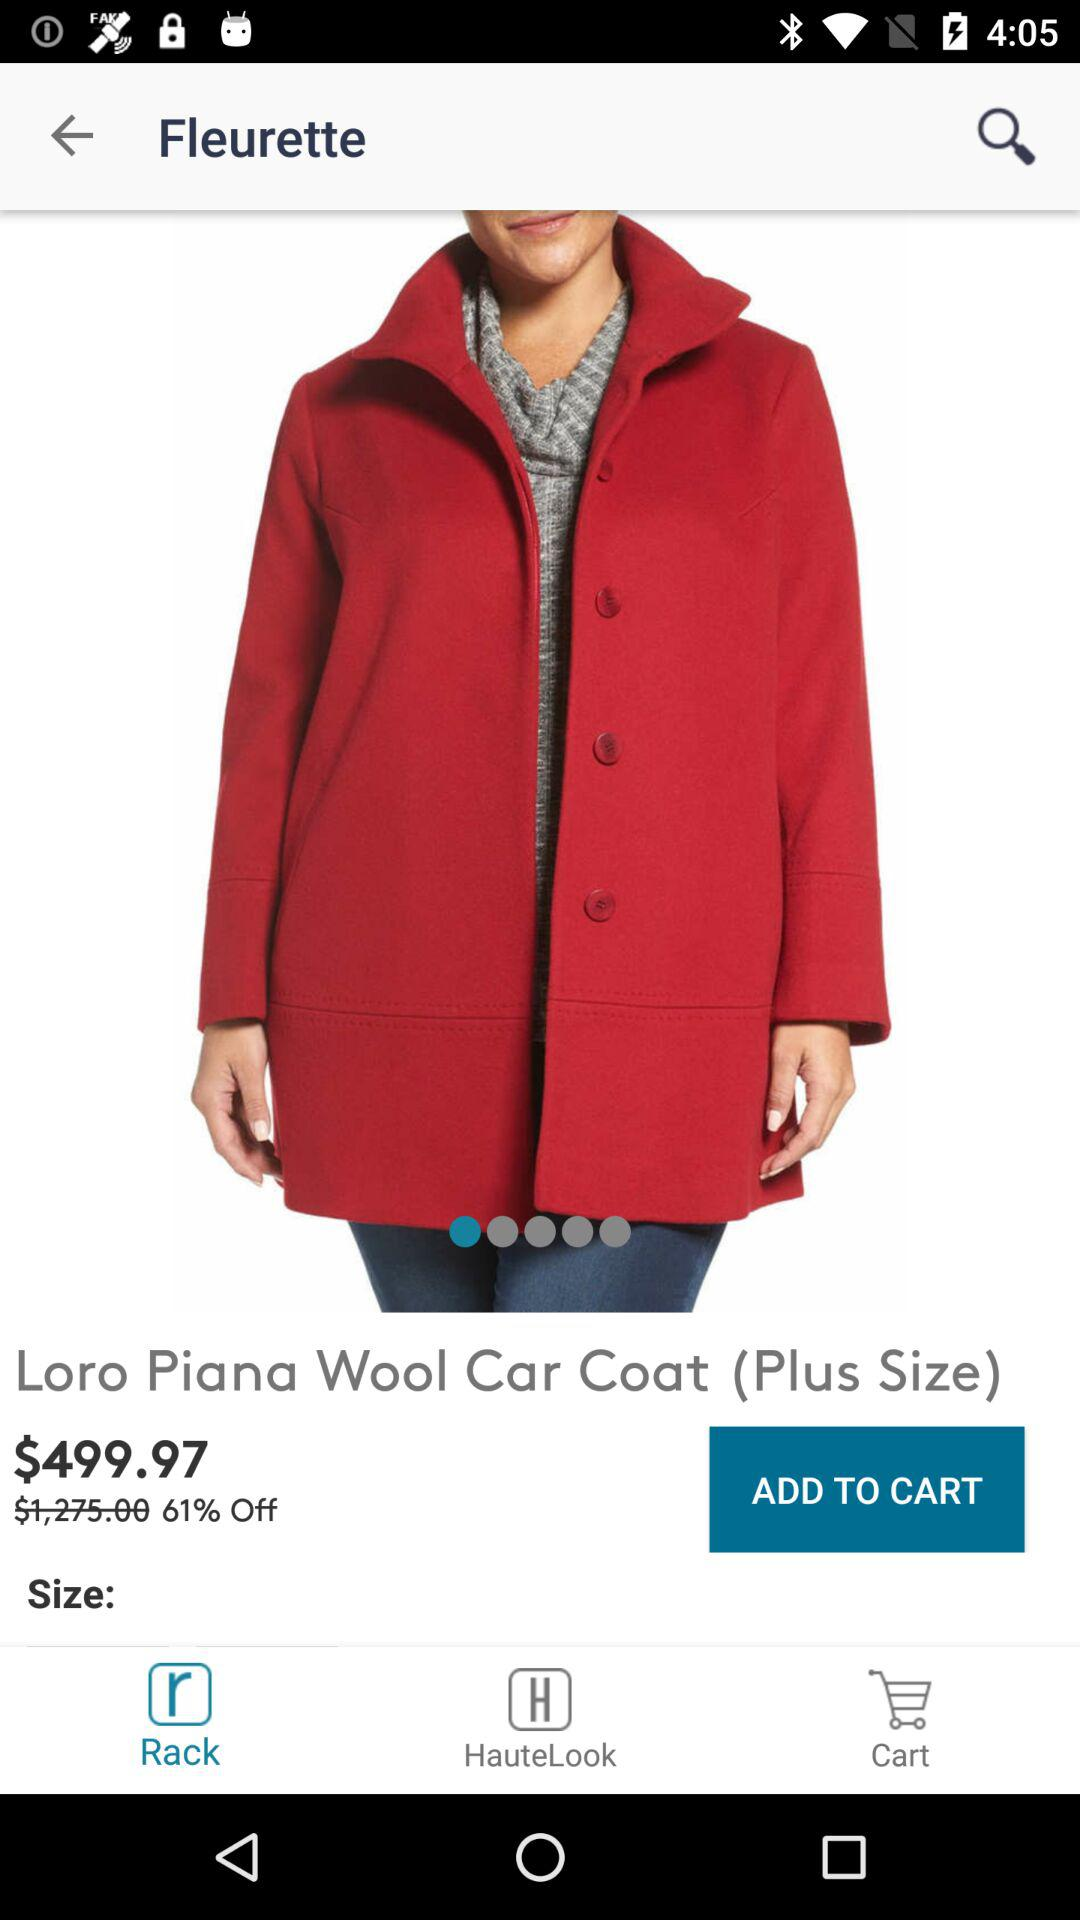Which tab has been selected? The tab "Rack" has been selected. 